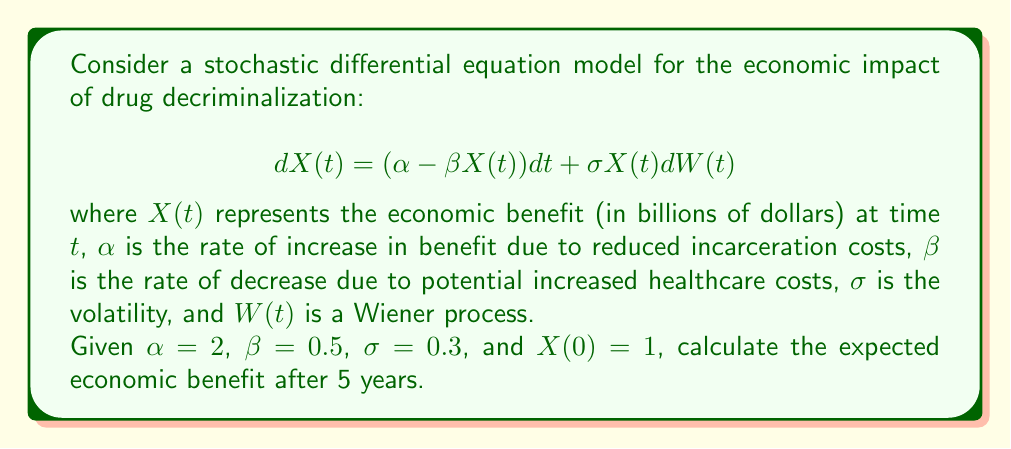Solve this math problem. To solve this problem, we'll follow these steps:

1) The given stochastic differential equation is a linear SDE, specifically the Ornstein-Uhlenbeck process.

2) For this process, the expected value at time $t$ is given by:

   $$E[X(t)] = X(0)e^{-\beta t} + \frac{\alpha}{\beta}(1 - e^{-\beta t})$$

3) We're given:
   $X(0) = 1$ (initial value)
   $\alpha = 2$ (rate of increase)
   $\beta = 0.5$ (rate of decrease)
   $t = 5$ (time in years)

4) Let's substitute these values into the formula:

   $$E[X(5)] = 1 \cdot e^{-0.5 \cdot 5} + \frac{2}{0.5}(1 - e^{-0.5 \cdot 5})$$

5) Simplify:
   $$E[X(5)] = e^{-2.5} + 4(1 - e^{-2.5})$$

6) Calculate:
   $$E[X(5)] \approx 0.0821 + 4(1 - 0.0821) = 0.0821 + 3.6716 = 3.7537$$

Therefore, the expected economic benefit after 5 years is approximately 3.7537 billion dollars.
Answer: $3.7537 billion 